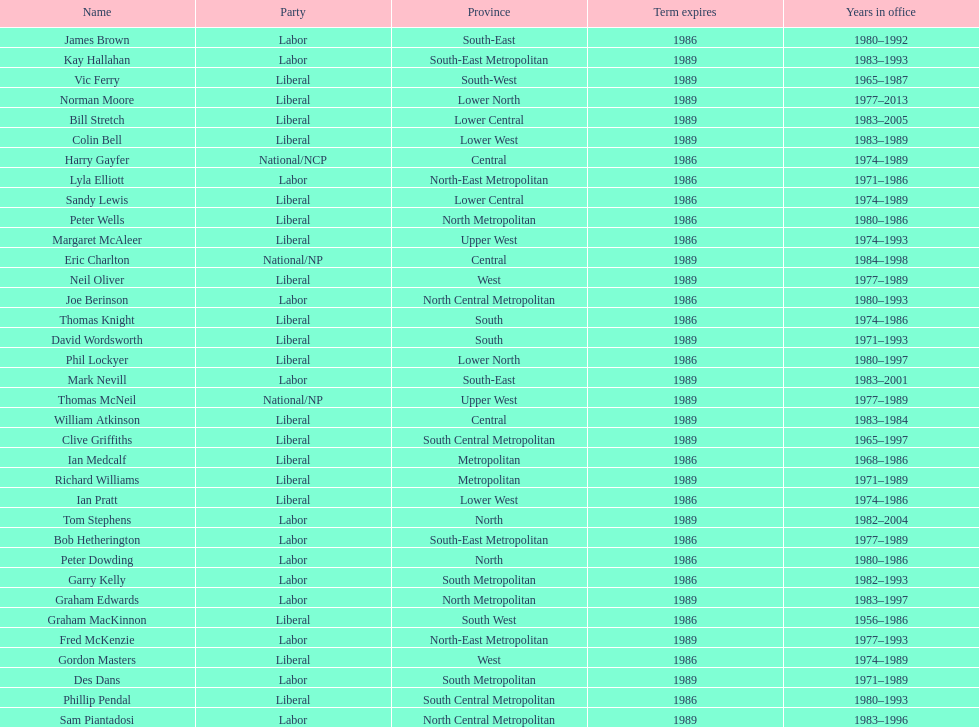Who has had the shortest term in office William Atkinson. 